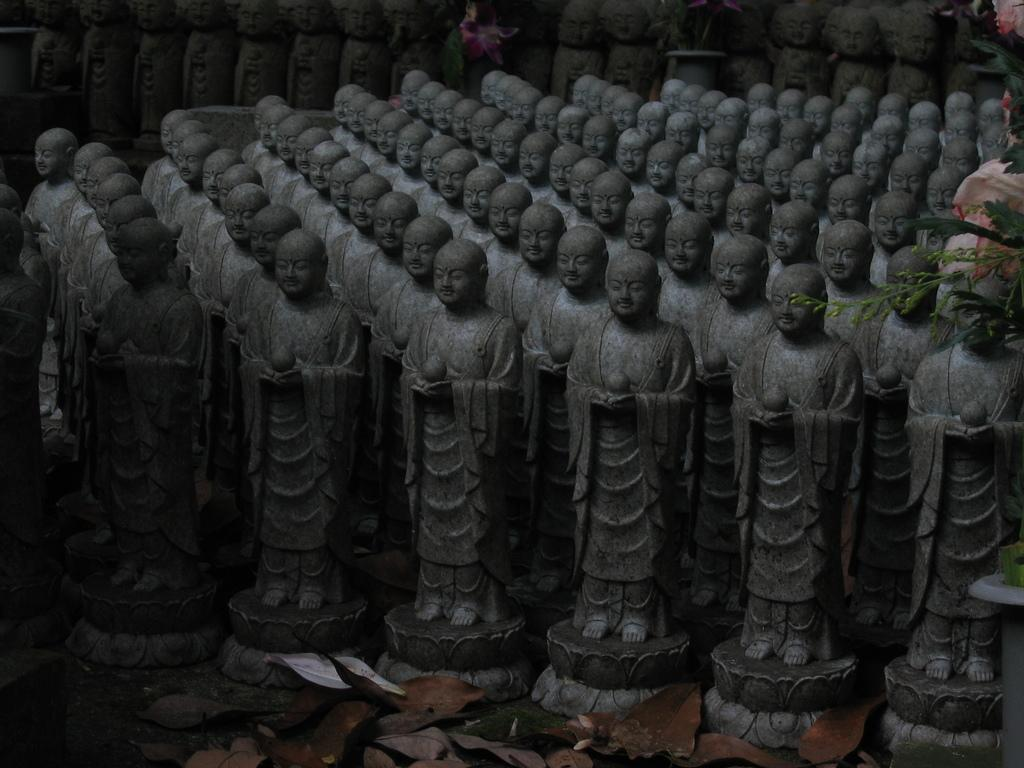What can be seen in the image besides the plant on the right side? There are statues in the image. Can you describe the plant in the image? The plant has leaves at the bottom of the image. What is the effect of the wish on the friction between the statues in the image? There is no mention of a wish or friction in the image, so it is not possible to determine any effect on the statues. 